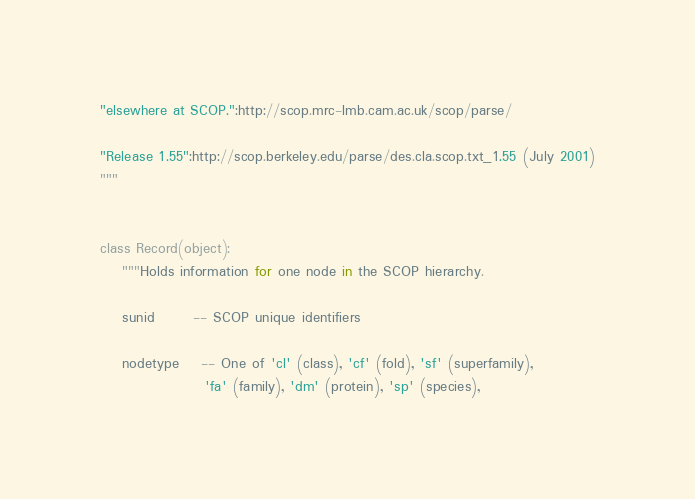<code> <loc_0><loc_0><loc_500><loc_500><_Python_>"elsewhere at SCOP.":http://scop.mrc-lmb.cam.ac.uk/scop/parse/
  
"Release 1.55":http://scop.berkeley.edu/parse/des.cla.scop.txt_1.55 (July 2001)
"""


class Record(object):
    """Holds information for one node in the SCOP hierarchy.

    sunid       -- SCOP unique identifiers

    nodetype    -- One of 'cl' (class), 'cf' (fold), 'sf' (superfamily),
                   'fa' (family), 'dm' (protein), 'sp' (species),</code> 